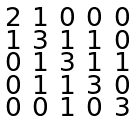Convert formula to latex. <formula><loc_0><loc_0><loc_500><loc_500>\begin{smallmatrix} 2 & 1 & 0 & 0 & 0 \\ 1 & 3 & 1 & 1 & 0 \\ 0 & 1 & 3 & 1 & 1 \\ 0 & 1 & 1 & 3 & 0 \\ 0 & 0 & 1 & 0 & 3 \end{smallmatrix}</formula> 